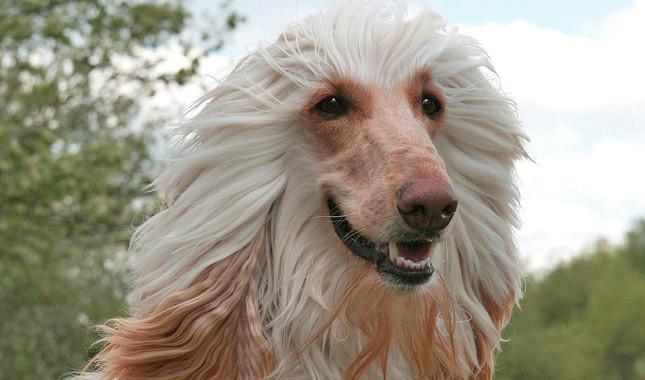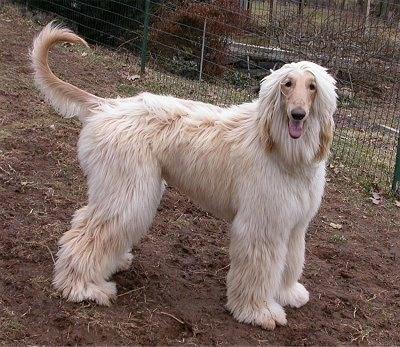The first image is the image on the left, the second image is the image on the right. Analyze the images presented: Is the assertion "There is more than one dog in one of the images." valid? Answer yes or no. No. 